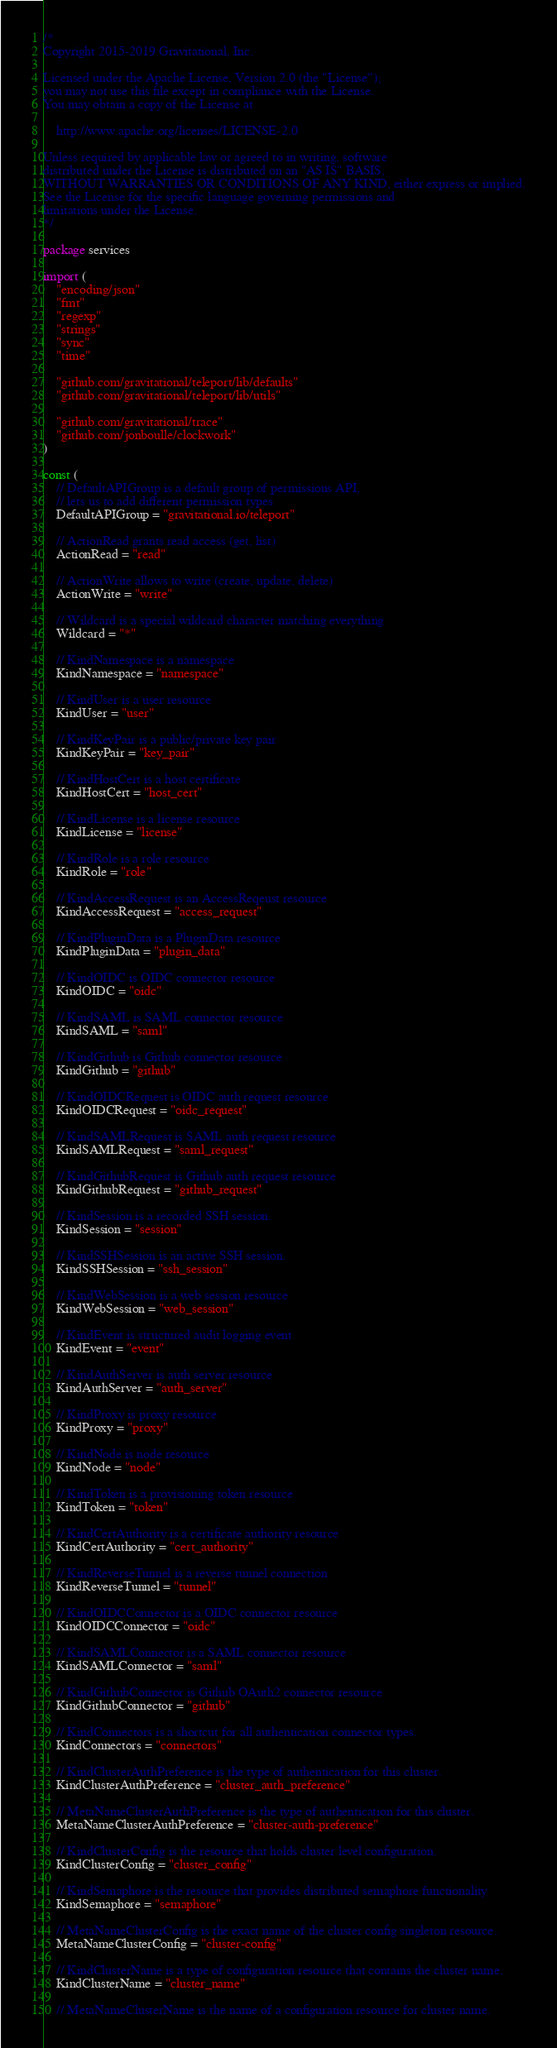<code> <loc_0><loc_0><loc_500><loc_500><_Go_>/*
Copyright 2015-2019 Gravitational, Inc.

Licensed under the Apache License, Version 2.0 (the "License");
you may not use this file except in compliance with the License.
You may obtain a copy of the License at

    http://www.apache.org/licenses/LICENSE-2.0

Unless required by applicable law or agreed to in writing, software
distributed under the License is distributed on an "AS IS" BASIS,
WITHOUT WARRANTIES OR CONDITIONS OF ANY KIND, either express or implied.
See the License for the specific language governing permissions and
limitations under the License.
*/

package services

import (
	"encoding/json"
	"fmt"
	"regexp"
	"strings"
	"sync"
	"time"

	"github.com/gravitational/teleport/lib/defaults"
	"github.com/gravitational/teleport/lib/utils"

	"github.com/gravitational/trace"
	"github.com/jonboulle/clockwork"
)

const (
	// DefaultAPIGroup is a default group of permissions API,
	// lets us to add different permission types
	DefaultAPIGroup = "gravitational.io/teleport"

	// ActionRead grants read access (get, list)
	ActionRead = "read"

	// ActionWrite allows to write (create, update, delete)
	ActionWrite = "write"

	// Wildcard is a special wildcard character matching everything
	Wildcard = "*"

	// KindNamespace is a namespace
	KindNamespace = "namespace"

	// KindUser is a user resource
	KindUser = "user"

	// KindKeyPair is a public/private key pair
	KindKeyPair = "key_pair"

	// KindHostCert is a host certificate
	KindHostCert = "host_cert"

	// KindLicense is a license resource
	KindLicense = "license"

	// KindRole is a role resource
	KindRole = "role"

	// KindAccessRequest is an AccessReqeust resource
	KindAccessRequest = "access_request"

	// KindPluginData is a PluginData resource
	KindPluginData = "plugin_data"

	// KindOIDC is OIDC connector resource
	KindOIDC = "oidc"

	// KindSAML is SAML connector resource
	KindSAML = "saml"

	// KindGithub is Github connector resource
	KindGithub = "github"

	// KindOIDCRequest is OIDC auth request resource
	KindOIDCRequest = "oidc_request"

	// KindSAMLRequest is SAML auth request resource
	KindSAMLRequest = "saml_request"

	// KindGithubRequest is Github auth request resource
	KindGithubRequest = "github_request"

	// KindSession is a recorded SSH session.
	KindSession = "session"

	// KindSSHSession is an active SSH session.
	KindSSHSession = "ssh_session"

	// KindWebSession is a web session resource
	KindWebSession = "web_session"

	// KindEvent is structured audit logging event
	KindEvent = "event"

	// KindAuthServer is auth server resource
	KindAuthServer = "auth_server"

	// KindProxy is proxy resource
	KindProxy = "proxy"

	// KindNode is node resource
	KindNode = "node"

	// KindToken is a provisioning token resource
	KindToken = "token"

	// KindCertAuthority is a certificate authority resource
	KindCertAuthority = "cert_authority"

	// KindReverseTunnel is a reverse tunnel connection
	KindReverseTunnel = "tunnel"

	// KindOIDCConnector is a OIDC connector resource
	KindOIDCConnector = "oidc"

	// KindSAMLConnector is a SAML connector resource
	KindSAMLConnector = "saml"

	// KindGithubConnector is Github OAuth2 connector resource
	KindGithubConnector = "github"

	// KindConnectors is a shortcut for all authentication connector types.
	KindConnectors = "connectors"

	// KindClusterAuthPreference is the type of authentication for this cluster.
	KindClusterAuthPreference = "cluster_auth_preference"

	// MetaNameClusterAuthPreference is the type of authentication for this cluster.
	MetaNameClusterAuthPreference = "cluster-auth-preference"

	// KindClusterConfig is the resource that holds cluster level configuration.
	KindClusterConfig = "cluster_config"

	// KindSemaphore is the resource that provides distributed semaphore functionality
	KindSemaphore = "semaphore"

	// MetaNameClusterConfig is the exact name of the cluster config singleton resource.
	MetaNameClusterConfig = "cluster-config"

	// KindClusterName is a type of configuration resource that contains the cluster name.
	KindClusterName = "cluster_name"

	// MetaNameClusterName is the name of a configuration resource for cluster name.</code> 